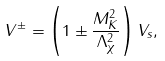Convert formula to latex. <formula><loc_0><loc_0><loc_500><loc_500>V ^ { \pm } = \left ( 1 \pm \frac { M _ { K } ^ { 2 } } { \Lambda _ { \chi } ^ { 2 } } \right ) V _ { s } ,</formula> 